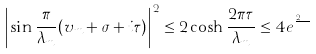Convert formula to latex. <formula><loc_0><loc_0><loc_500><loc_500>\left | \sin \frac { \pi } { \lambda _ { m } } ( v _ { m } + \sigma + i \tau ) \right | ^ { 2 } \leq 2 \cosh \frac { 2 \pi \tau } { \lambda _ { m } } \leq 4 e ^ { \frac { 2 \pi \tau } { \lambda _ { m } } }</formula> 